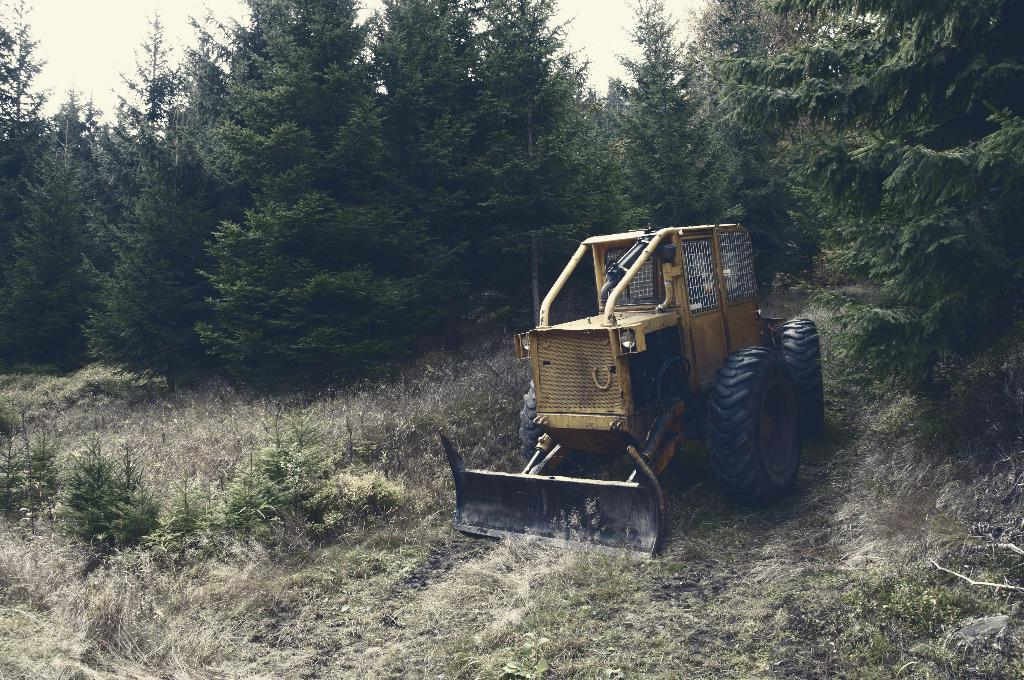What is the main subject of the image? The main subject of the image is a bulldozer. What type of terrain is visible at the bottom of the image? There is grass at the bottom of the image. What can be seen in the background of the image? There are trees in the background of the image. What is visible at the top of the image? The sky is visible at the top of the image. How does the bulldozer maintain its balance while using a toothbrush in the image? There is no toothbrush present in the image, and the bulldozer is not using any such object. 